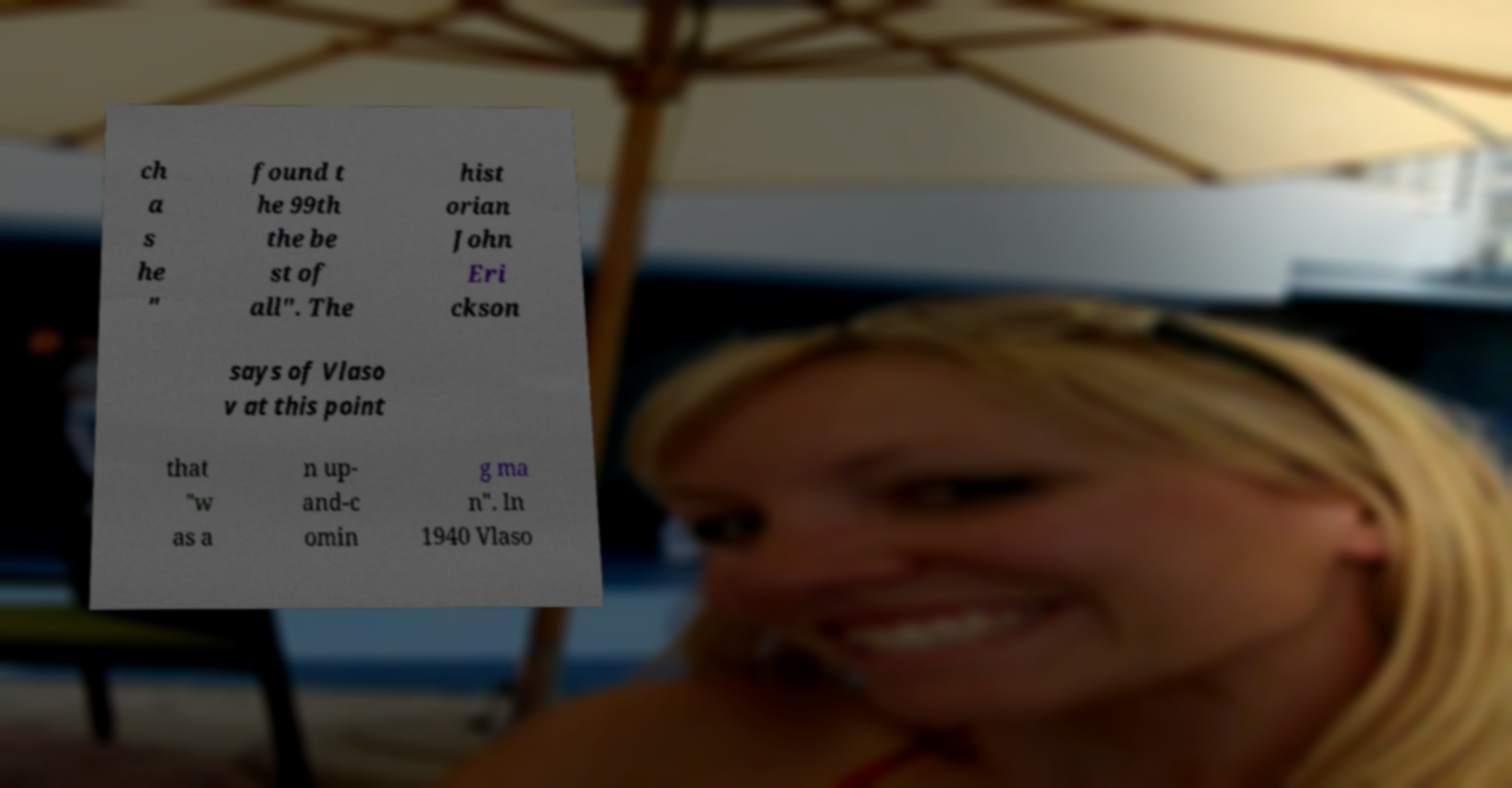For documentation purposes, I need the text within this image transcribed. Could you provide that? ch a s he " found t he 99th the be st of all". The hist orian John Eri ckson says of Vlaso v at this point that "w as a n up- and-c omin g ma n". In 1940 Vlaso 